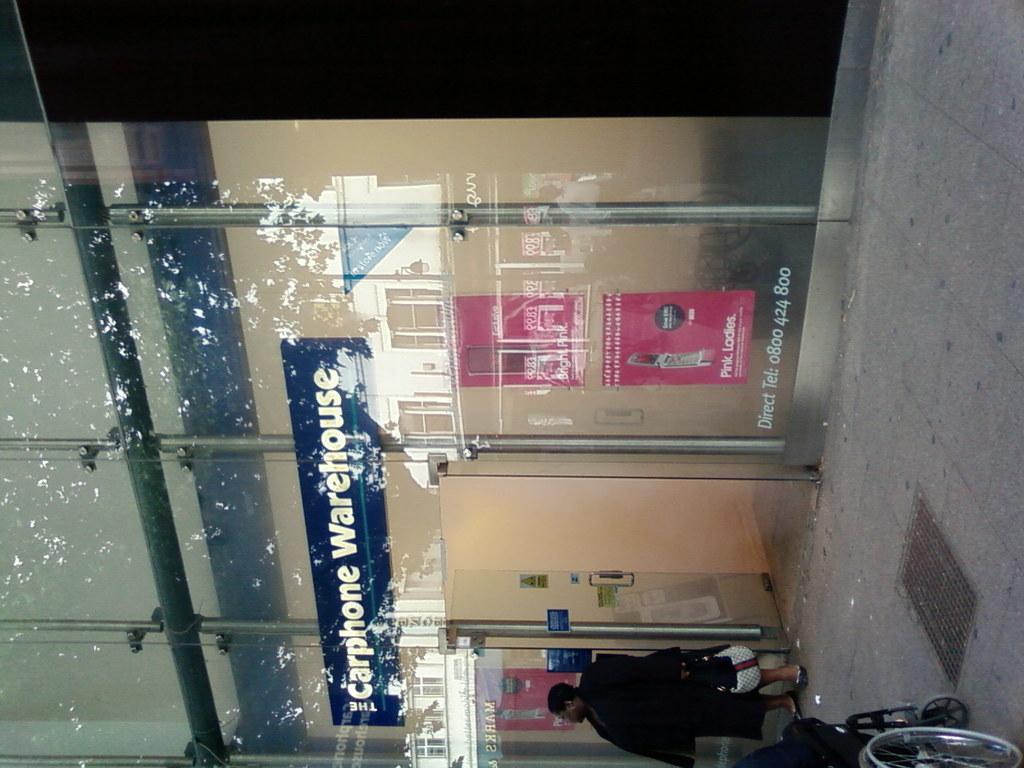Could you give a brief overview of what you see in this image? In this image we can see a big shop with glass on which we can see "Carphone Warehouse" is written. 